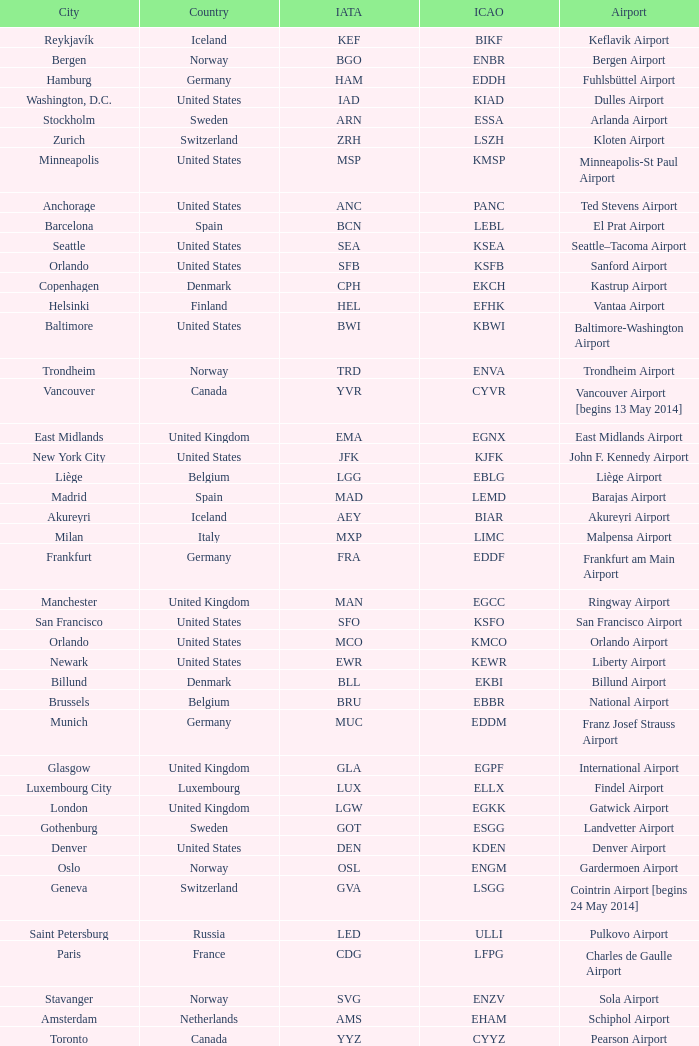What Airport's IATA is SEA? Seattle–Tacoma Airport. 